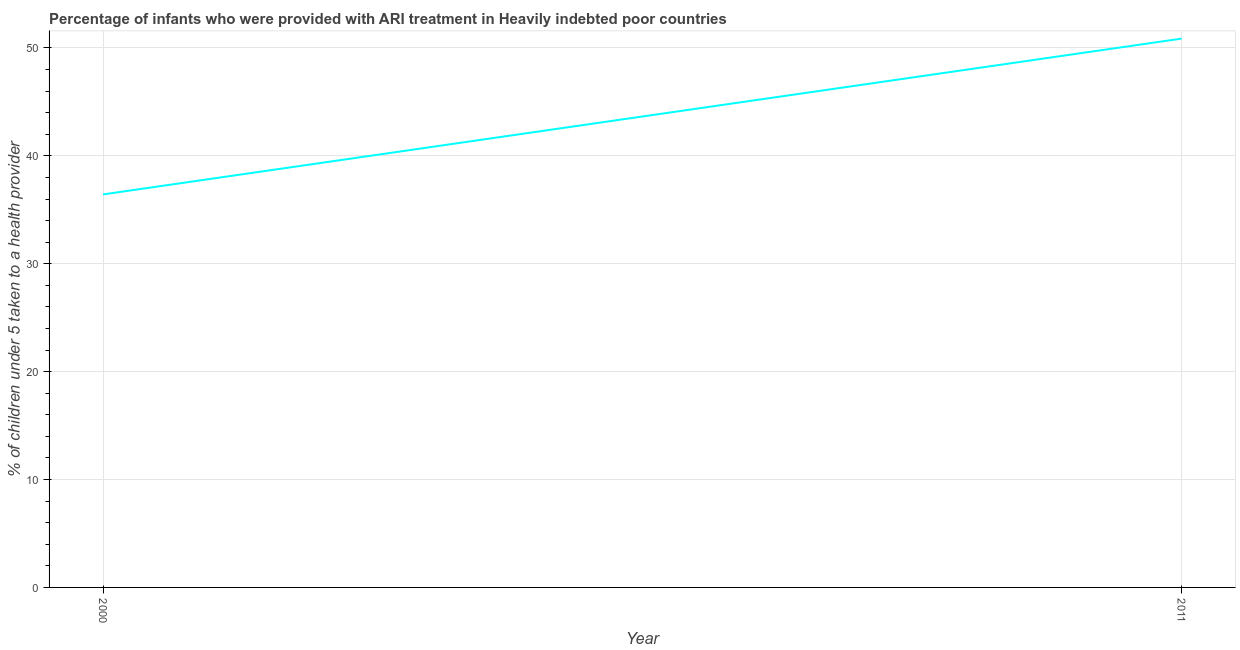What is the percentage of children who were provided with ari treatment in 2000?
Provide a succinct answer. 36.43. Across all years, what is the maximum percentage of children who were provided with ari treatment?
Your answer should be compact. 50.87. Across all years, what is the minimum percentage of children who were provided with ari treatment?
Make the answer very short. 36.43. In which year was the percentage of children who were provided with ari treatment maximum?
Provide a succinct answer. 2011. In which year was the percentage of children who were provided with ari treatment minimum?
Offer a terse response. 2000. What is the sum of the percentage of children who were provided with ari treatment?
Keep it short and to the point. 87.29. What is the difference between the percentage of children who were provided with ari treatment in 2000 and 2011?
Provide a short and direct response. -14.44. What is the average percentage of children who were provided with ari treatment per year?
Offer a terse response. 43.65. What is the median percentage of children who were provided with ari treatment?
Provide a short and direct response. 43.65. In how many years, is the percentage of children who were provided with ari treatment greater than 42 %?
Offer a terse response. 1. Do a majority of the years between 2011 and 2000 (inclusive) have percentage of children who were provided with ari treatment greater than 24 %?
Your answer should be compact. No. What is the ratio of the percentage of children who were provided with ari treatment in 2000 to that in 2011?
Your response must be concise. 0.72. Is the percentage of children who were provided with ari treatment in 2000 less than that in 2011?
Give a very brief answer. Yes. How many years are there in the graph?
Provide a short and direct response. 2. What is the difference between two consecutive major ticks on the Y-axis?
Make the answer very short. 10. Are the values on the major ticks of Y-axis written in scientific E-notation?
Keep it short and to the point. No. Does the graph contain any zero values?
Make the answer very short. No. What is the title of the graph?
Your answer should be very brief. Percentage of infants who were provided with ARI treatment in Heavily indebted poor countries. What is the label or title of the X-axis?
Keep it short and to the point. Year. What is the label or title of the Y-axis?
Offer a terse response. % of children under 5 taken to a health provider. What is the % of children under 5 taken to a health provider in 2000?
Offer a terse response. 36.43. What is the % of children under 5 taken to a health provider in 2011?
Offer a terse response. 50.87. What is the difference between the % of children under 5 taken to a health provider in 2000 and 2011?
Make the answer very short. -14.44. What is the ratio of the % of children under 5 taken to a health provider in 2000 to that in 2011?
Your answer should be very brief. 0.72. 